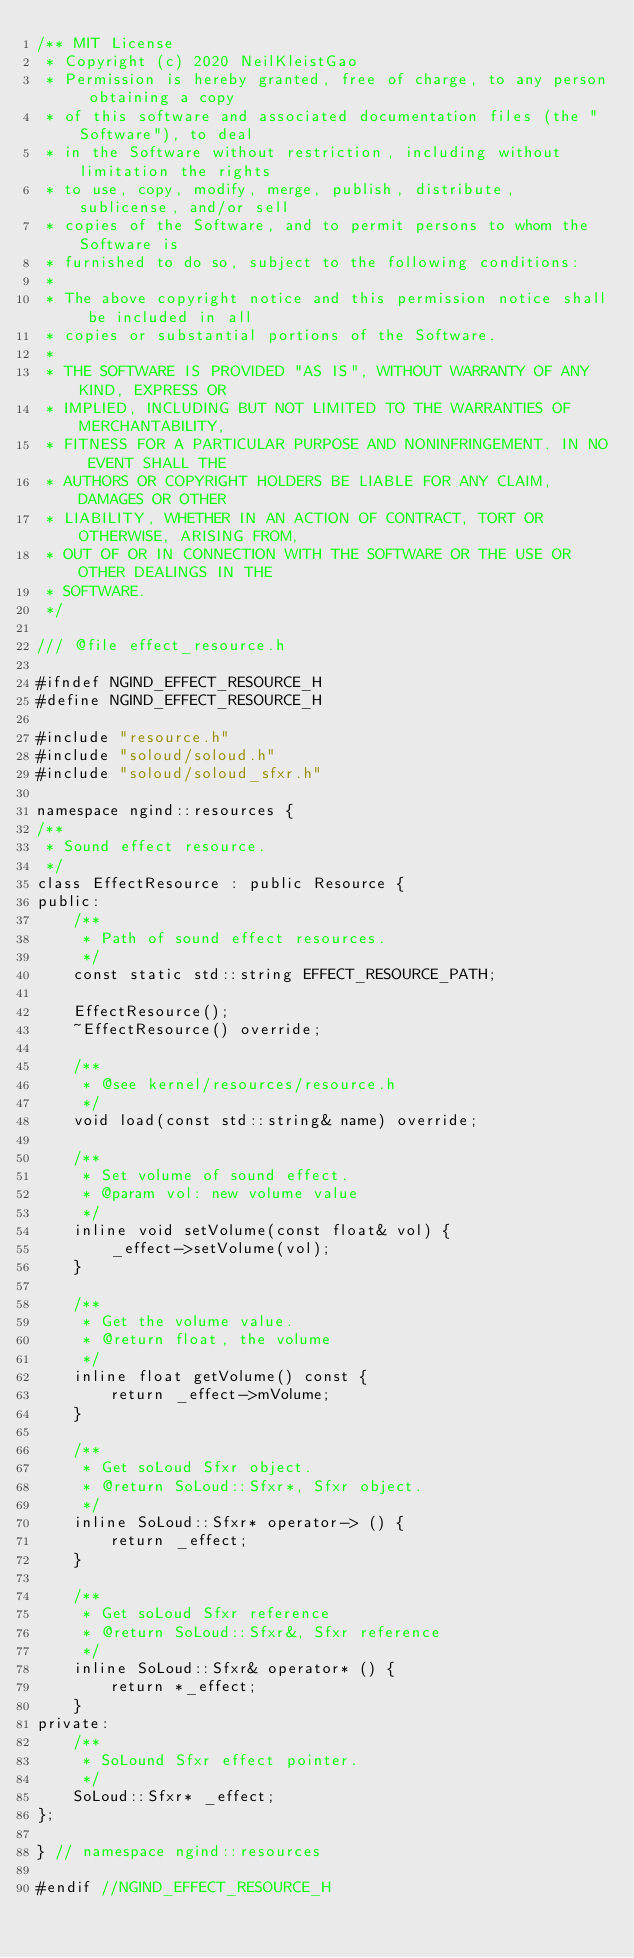<code> <loc_0><loc_0><loc_500><loc_500><_C_>/** MIT License
 * Copyright (c) 2020 NeilKleistGao
 * Permission is hereby granted, free of charge, to any person obtaining a copy
 * of this software and associated documentation files (the "Software"), to deal
 * in the Software without restriction, including without limitation the rights
 * to use, copy, modify, merge, publish, distribute, sublicense, and/or sell
 * copies of the Software, and to permit persons to whom the Software is
 * furnished to do so, subject to the following conditions:
 *
 * The above copyright notice and this permission notice shall be included in all
 * copies or substantial portions of the Software.
 *
 * THE SOFTWARE IS PROVIDED "AS IS", WITHOUT WARRANTY OF ANY KIND, EXPRESS OR
 * IMPLIED, INCLUDING BUT NOT LIMITED TO THE WARRANTIES OF MERCHANTABILITY,
 * FITNESS FOR A PARTICULAR PURPOSE AND NONINFRINGEMENT. IN NO EVENT SHALL THE
 * AUTHORS OR COPYRIGHT HOLDERS BE LIABLE FOR ANY CLAIM, DAMAGES OR OTHER
 * LIABILITY, WHETHER IN AN ACTION OF CONTRACT, TORT OR OTHERWISE, ARISING FROM,
 * OUT OF OR IN CONNECTION WITH THE SOFTWARE OR THE USE OR OTHER DEALINGS IN THE
 * SOFTWARE.
 */

/// @file effect_resource.h

#ifndef NGIND_EFFECT_RESOURCE_H
#define NGIND_EFFECT_RESOURCE_H

#include "resource.h"
#include "soloud/soloud.h"
#include "soloud/soloud_sfxr.h"

namespace ngind::resources {
/**
 * Sound effect resource.
 */
class EffectResource : public Resource {
public:
    /**
     * Path of sound effect resources.
     */
    const static std::string EFFECT_RESOURCE_PATH;

    EffectResource();
    ~EffectResource() override;

    /**
     * @see kernel/resources/resource.h
     */
    void load(const std::string& name) override;

    /**
     * Set volume of sound effect.
     * @param vol: new volume value
     */
    inline void setVolume(const float& vol) {
        _effect->setVolume(vol);
    }

    /**
     * Get the volume value.
     * @return float, the volume
     */
    inline float getVolume() const {
        return _effect->mVolume;
    }

    /**
     * Get soLoud Sfxr object.
     * @return SoLoud::Sfxr*, Sfxr object.
     */
    inline SoLoud::Sfxr* operator-> () {
        return _effect;
    }

    /**
     * Get soLoud Sfxr reference
     * @return SoLoud::Sfxr&, Sfxr reference
     */
    inline SoLoud::Sfxr& operator* () {
        return *_effect;
    }
private:
    /**
     * SoLound Sfxr effect pointer.
     */
    SoLoud::Sfxr* _effect;
};

} // namespace ngind::resources

#endif //NGIND_EFFECT_RESOURCE_H
</code> 